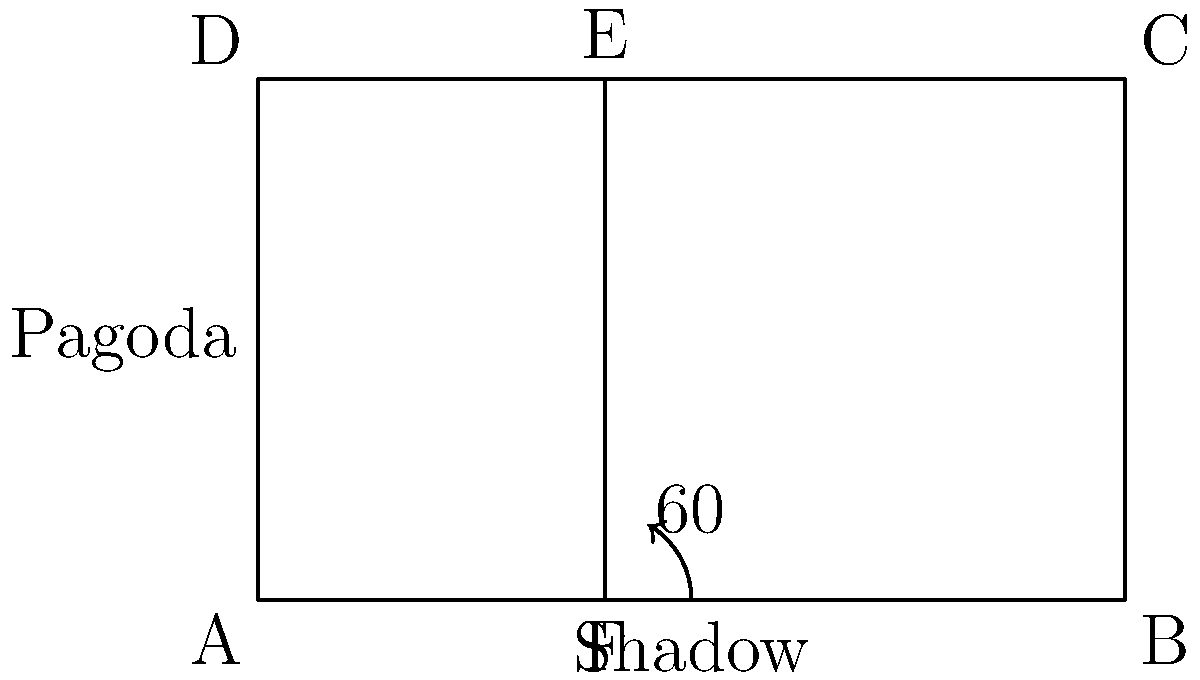In ancient China, a scholar is trying to measure the height of a pagoda using its shadow. He observes that when the sun is at a 60° angle above the horizon, the shadow of the pagoda is 5 meters long. What is the height of the pagoda? To solve this problem, we can use trigonometry, specifically the tangent function. Let's break it down step by step:

1) In a right triangle, tangent of an angle is the ratio of the opposite side to the adjacent side.

2) In this case:
   - The angle is 60°
   - The adjacent side is the length of the shadow (5 meters)
   - The opposite side is the height of the pagoda (what we're trying to find)

3) Let's call the height of the pagoda $h$. We can write the equation:

   $\tan 60° = \frac{h}{5}$

4) We know that $\tan 60° = \sqrt{3}$, so we can rewrite the equation:

   $\sqrt{3} = \frac{h}{5}$

5) To solve for $h$, multiply both sides by 5:

   $5\sqrt{3} = h$

6) This gives us the height of the pagoda in meters.

7) If we want to calculate the numerical value:
   $5\sqrt{3} \approx 8.66$ meters

Thus, the pagoda is approximately 8.66 meters tall.
Answer: $5\sqrt{3}$ meters 